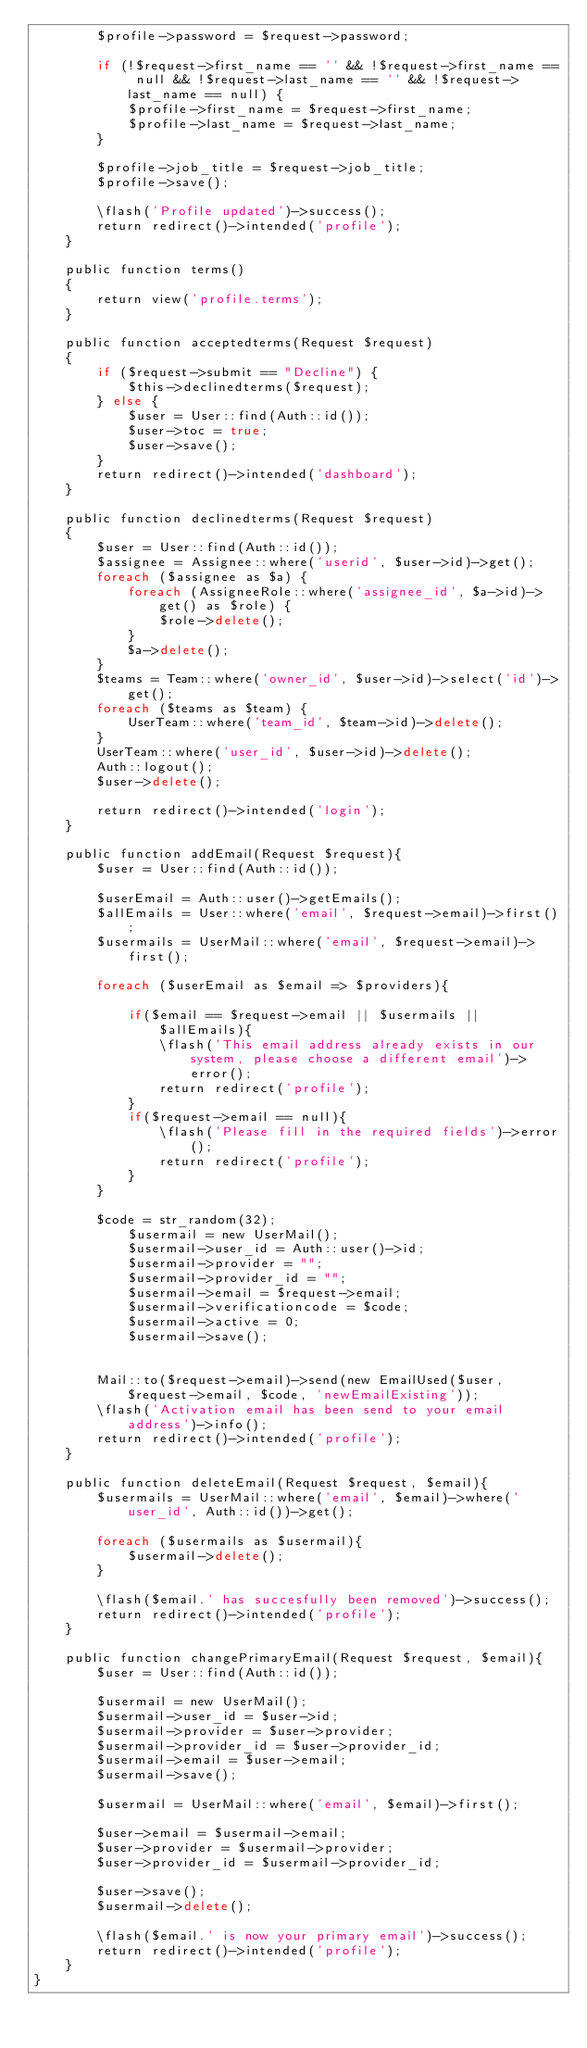Convert code to text. <code><loc_0><loc_0><loc_500><loc_500><_PHP_>        $profile->password = $request->password;

        if (!$request->first_name == '' && !$request->first_name == null && !$request->last_name == '' && !$request->last_name == null) {
            $profile->first_name = $request->first_name;
            $profile->last_name = $request->last_name;
        }

        $profile->job_title = $request->job_title;
        $profile->save();

        \flash('Profile updated')->success();
        return redirect()->intended('profile');
    }

    public function terms()
    {
        return view('profile.terms');
    }

    public function acceptedterms(Request $request)
    {
        if ($request->submit == "Decline") {
            $this->declinedterms($request);
        } else {
            $user = User::find(Auth::id());
            $user->toc = true;
            $user->save();
        }
        return redirect()->intended('dashboard');
    }

    public function declinedterms(Request $request)
    {
        $user = User::find(Auth::id());
        $assignee = Assignee::where('userid', $user->id)->get();
        foreach ($assignee as $a) {
            foreach (AssigneeRole::where('assignee_id', $a->id)->get() as $role) {
                $role->delete();
            }
            $a->delete();
        }
        $teams = Team::where('owner_id', $user->id)->select('id')->get();
        foreach ($teams as $team) {
            UserTeam::where('team_id', $team->id)->delete();
        }
        UserTeam::where('user_id', $user->id)->delete();
        Auth::logout();
        $user->delete();

        return redirect()->intended('login');
    }

    public function addEmail(Request $request){
        $user = User::find(Auth::id());

        $userEmail = Auth::user()->getEmails();
        $allEmails = User::where('email', $request->email)->first();
        $usermails = UserMail::where('email', $request->email)->first();

        foreach ($userEmail as $email => $providers){

            if($email == $request->email || $usermails || $allEmails){
                \flash('This email address already exists in our system, please choose a different email')->error();
                return redirect('profile');
            }
            if($request->email == null){
                \flash('Please fill in the required fields')->error();
                return redirect('profile');
            }
        }

        $code = str_random(32);
            $usermail = new UserMail();
            $usermail->user_id = Auth::user()->id;
            $usermail->provider = "";
            $usermail->provider_id = "";
            $usermail->email = $request->email;
            $usermail->verificationcode = $code;
            $usermail->active = 0;
            $usermail->save();


        Mail::to($request->email)->send(new EmailUsed($user,  $request->email, $code, 'newEmailExisting'));
        \flash('Activation email has been send to your email address')->info();
        return redirect()->intended('profile');
    }

    public function deleteEmail(Request $request, $email){
        $usermails = UserMail::where('email', $email)->where('user_id', Auth::id())->get();

        foreach ($usermails as $usermail){
            $usermail->delete();
        }

        \flash($email.' has succesfully been removed')->success();
        return redirect()->intended('profile');
    }

    public function changePrimaryEmail(Request $request, $email){
        $user = User::find(Auth::id());

        $usermail = new UserMail();
        $usermail->user_id = $user->id;
        $usermail->provider = $user->provider;
        $usermail->provider_id = $user->provider_id;
        $usermail->email = $user->email;
        $usermail->save();

        $usermail = UserMail::where('email', $email)->first();

        $user->email = $usermail->email;
        $user->provider = $usermail->provider;
        $user->provider_id = $usermail->provider_id;

        $user->save();
        $usermail->delete();

        \flash($email.' is now your primary email')->success();
        return redirect()->intended('profile');
    }
}
</code> 